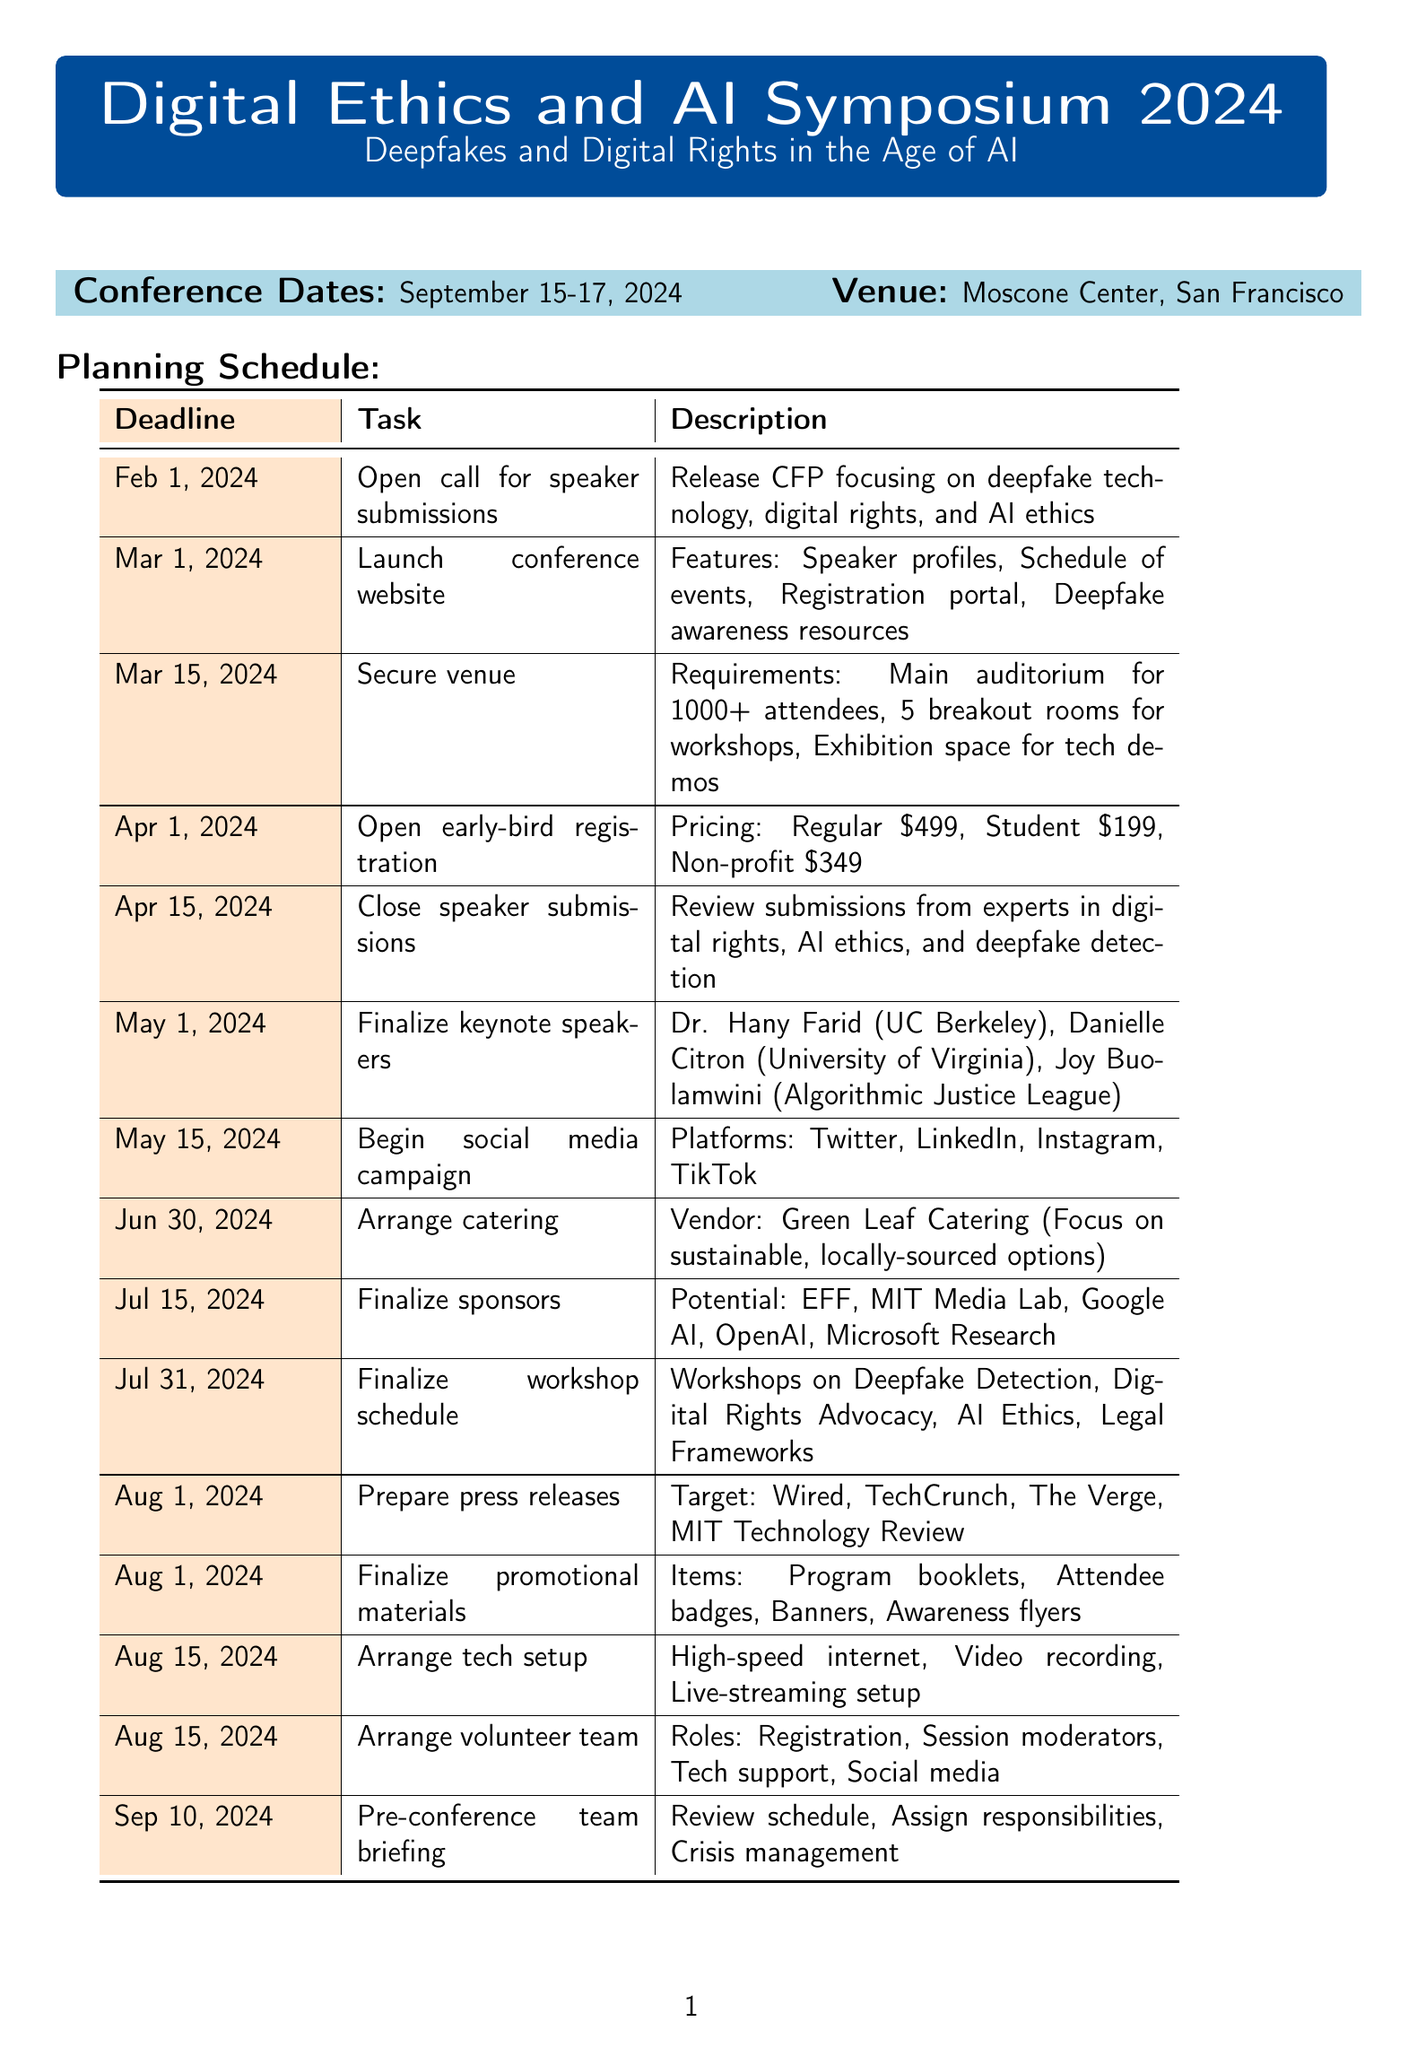what is the conference name? The conference name is explicitly stated at the beginning of the document.
Answer: Digital Ethics and AI Symposium 2024 what are the conference dates? The document lists the start and end dates for the conference.
Answer: September 15-17, 2024 when is the deadline for speaker submissions? The deadline is mentioned in the planning section of the document.
Answer: April 15, 2024 who are the keynote speakers? The document specifies the names and affiliations of the keynote speakers as part of the planning details.
Answer: Dr. Hany Farid, Danielle Citron, Joy Buolamwini what is the registration price for students? The pricing information for early-bird registration is outlined in the document.
Answer: $199 which venue will the conference be held at? The document clearly states the venue for the event in the planning section.
Answer: Moscone Center, San Francisco what is the deadline for finalizing sponsors? This information is included in the planning schedule with a specific date mentioned.
Answer: July 15, 2024 how many breakout rooms are required for the venue? The venue requirements detail the number of breakout rooms needed, which can be found in the document.
Answer: 5 what is the focus of the catering arrangement? The document outlines the vendor and emphasizes the focus regarding the menu category.
Answer: Sustainable, locally-sourced options 